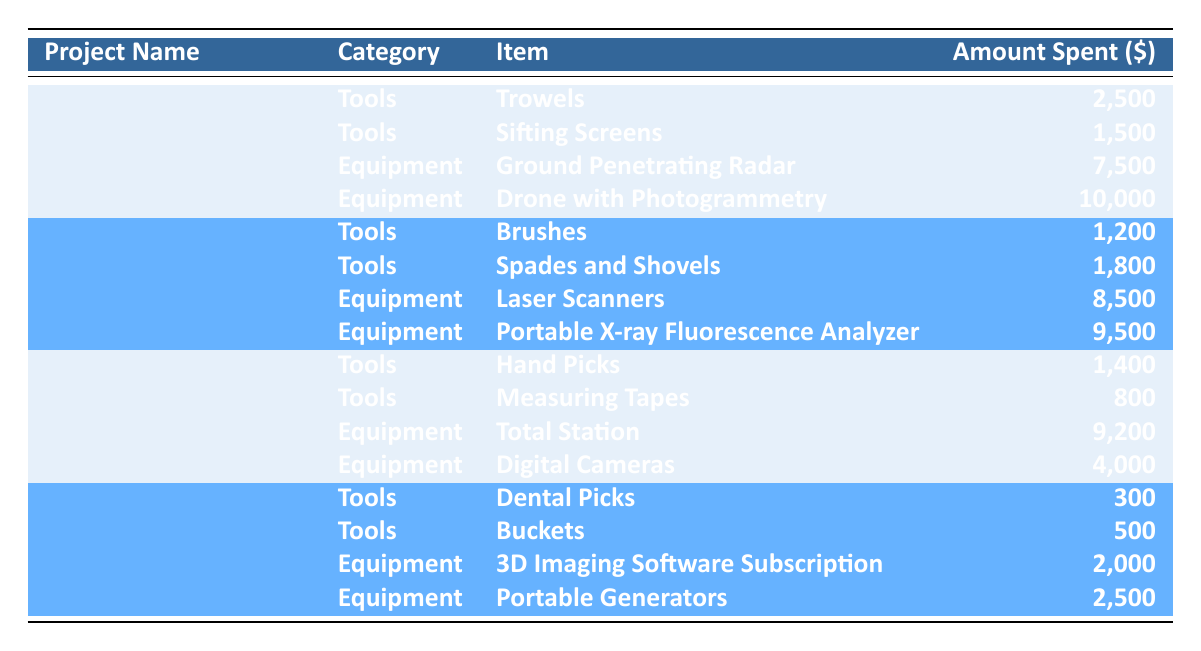What is the total amount spent on tools for the Heuneburg Excavation? The Heuneburg Excavation has two tool expenditures: Trowels for 2,500 dollars and Sifting Screens for 1,500 dollars. Adding these amounts gives 2,500 + 1,500 = 4,000 dollars
Answer: 4,000 Which project had the highest expenditure on equipment? By examining the data, the expenditures for equipment are as follows: Heuneburg Excavation (7,500 + 10,000), Viking Burial Mounds (8,500 + 9,500), Nydam Bog Excavation (9,200 + 4,000), and Arzhan Kurgan (2,000 + 2,500). Summing each gives 17,500, 18,000, 13,200, and 4,500 respectively. The highest is 18,000 dollars for the Viking Burial Mounds
Answer: Viking Burial Mounds Did the Nydam Bog Excavation spend more on tools than on equipment? The Nydam Bog Excavation spent 1,400 on Hand Picks and 800 on Measuring Tapes, totaling 2,200 on tools. For equipment, they spent 9,200 on Total Station and 4,000 on Digital Cameras, totaling 13,200. Since 2,200 is less than 13,200, the answer is no
Answer: No What is the average expenditure per project for tools across all projects? The total expenditure on tools across all projects is: Heuneburg (4,000) + Viking Burial Mounds (3,000) + Nydam Bog (2,200) + Arzhan Kurgan (800), which totals 10,000. There are four projects, so the average is 10,000 / 4 = 2,500 dollars
Answer: 2,500 Which tool was the least expensive purchased for any of the projects? Reviewing the tool expenditures, the items are: Trowels (2,500), Sifting Screens (1,500), Brushes (1,200), Spades and Shovels (1,800), Hand Picks (1,400), Measuring Tapes (800), Dental Picks (300), and Buckets (500). The least expensive is 300 for Dental Picks
Answer: Dental Picks What was the total expenditure for the Arzhan Kurgan project? The expenditures for Arzhan Kurgan are: Dental Picks (300), Buckets (500), 3D Imaging Software Subscription (2,000), and Portable Generators (2,500). Adding these gives 300 + 500 + 2,000 + 2,500 = 5,300 dollars
Answer: 5,300 Was the expenditure on Equipment for the Viking Burial Mounds project greater than that for the Heuneburg Excavation project? The Viking Burial Mounds spent 8,500 on Laser Scanners and 9,500 on Portable X-ray Fluorescence Analyzer, totaling 18,000 dollars. The Heuneburg Excavation spent 7,500 on Ground Penetrating Radar and 10,000 on Drone with Photogrammetry, totaling 17,500 dollars. Since 18,000 is greater than 17,500, the answer is yes
Answer: Yes How much more was spent on equipment in the Nydam Bog Excavation than on tools? Nydam Bog Excavation's tool expenditure is 2,200 (1,400 + 800) and equipment expenditure is 13,200 (9,200 + 4,000). The difference is 13,200 - 2,200 = 11,000 dollars
Answer: 11,000 What percentage of the total expenditure does the Drone with Photogrammetry represent for the Heuneburg Excavation? For Heuneburg Excavation, the total spent is 4,000 (tools) + 17,500 (equipment) = 21,500 dollars, and the Drone with Photogrammetry costs 10,000 dollars. The percentage is (10,000 / 21,500) * 100 = approximately 46.5%
Answer: Approximately 46.5% 